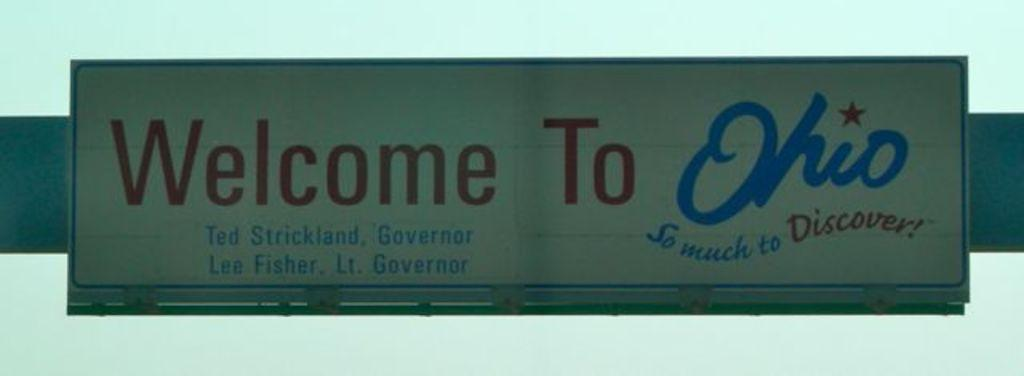<image>
Create a compact narrative representing the image presented. the label welcome to ohio that is on a sign 